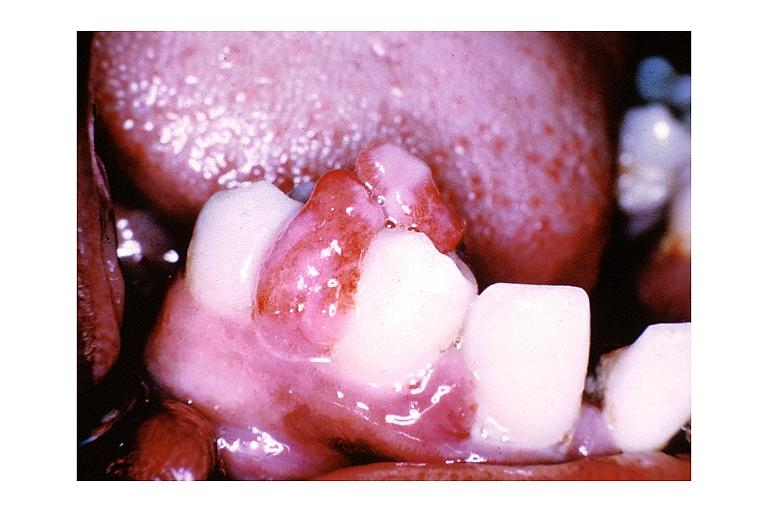what does this image show?
Answer the question using a single word or phrase. Pyogenic granuloma 